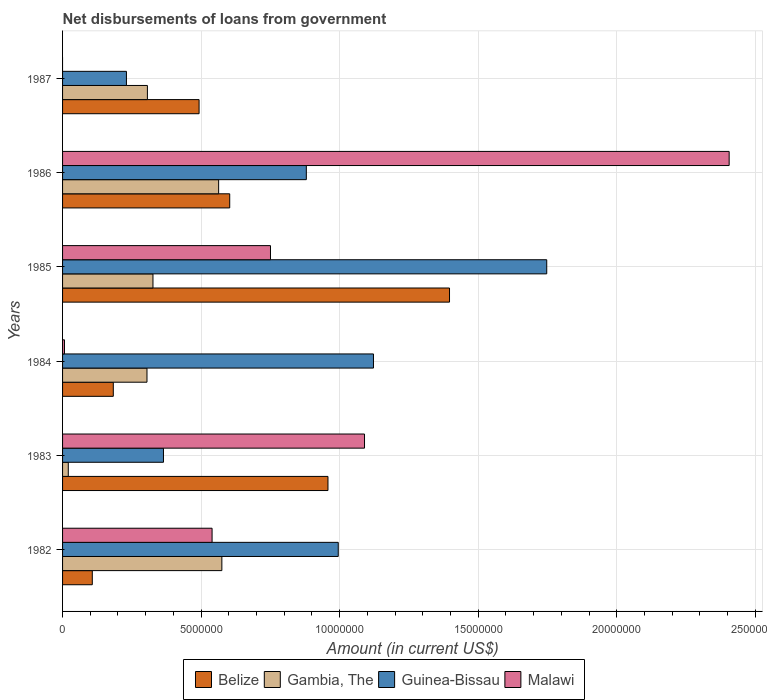How many different coloured bars are there?
Keep it short and to the point. 4. How many groups of bars are there?
Make the answer very short. 6. Are the number of bars on each tick of the Y-axis equal?
Your answer should be very brief. No. How many bars are there on the 5th tick from the top?
Your answer should be compact. 4. How many bars are there on the 6th tick from the bottom?
Offer a very short reply. 3. What is the amount of loan disbursed from government in Malawi in 1983?
Offer a very short reply. 1.09e+07. Across all years, what is the maximum amount of loan disbursed from government in Guinea-Bissau?
Provide a short and direct response. 1.75e+07. Across all years, what is the minimum amount of loan disbursed from government in Gambia, The?
Ensure brevity in your answer.  2.06e+05. In which year was the amount of loan disbursed from government in Malawi maximum?
Make the answer very short. 1986. What is the total amount of loan disbursed from government in Guinea-Bissau in the graph?
Give a very brief answer. 5.34e+07. What is the difference between the amount of loan disbursed from government in Belize in 1982 and that in 1986?
Provide a succinct answer. -4.96e+06. What is the difference between the amount of loan disbursed from government in Malawi in 1986 and the amount of loan disbursed from government in Belize in 1982?
Make the answer very short. 2.30e+07. What is the average amount of loan disbursed from government in Gambia, The per year?
Your response must be concise. 3.49e+06. In the year 1982, what is the difference between the amount of loan disbursed from government in Guinea-Bissau and amount of loan disbursed from government in Malawi?
Your response must be concise. 4.55e+06. In how many years, is the amount of loan disbursed from government in Belize greater than 12000000 US$?
Ensure brevity in your answer.  1. What is the ratio of the amount of loan disbursed from government in Guinea-Bissau in 1984 to that in 1987?
Offer a very short reply. 4.87. What is the difference between the highest and the second highest amount of loan disbursed from government in Malawi?
Provide a succinct answer. 1.32e+07. What is the difference between the highest and the lowest amount of loan disbursed from government in Belize?
Your answer should be compact. 1.29e+07. In how many years, is the amount of loan disbursed from government in Belize greater than the average amount of loan disbursed from government in Belize taken over all years?
Offer a terse response. 2. Is it the case that in every year, the sum of the amount of loan disbursed from government in Malawi and amount of loan disbursed from government in Belize is greater than the amount of loan disbursed from government in Guinea-Bissau?
Make the answer very short. No. How many bars are there?
Give a very brief answer. 23. Are all the bars in the graph horizontal?
Give a very brief answer. Yes. How many years are there in the graph?
Ensure brevity in your answer.  6. What is the difference between two consecutive major ticks on the X-axis?
Offer a very short reply. 5.00e+06. Are the values on the major ticks of X-axis written in scientific E-notation?
Provide a succinct answer. No. Does the graph contain grids?
Your response must be concise. Yes. How many legend labels are there?
Your answer should be compact. 4. How are the legend labels stacked?
Provide a short and direct response. Horizontal. What is the title of the graph?
Ensure brevity in your answer.  Net disbursements of loans from government. Does "Benin" appear as one of the legend labels in the graph?
Provide a succinct answer. No. What is the label or title of the X-axis?
Provide a succinct answer. Amount (in current US$). What is the label or title of the Y-axis?
Your response must be concise. Years. What is the Amount (in current US$) of Belize in 1982?
Your response must be concise. 1.07e+06. What is the Amount (in current US$) in Gambia, The in 1982?
Offer a terse response. 5.75e+06. What is the Amount (in current US$) of Guinea-Bissau in 1982?
Offer a very short reply. 9.95e+06. What is the Amount (in current US$) of Malawi in 1982?
Provide a short and direct response. 5.40e+06. What is the Amount (in current US$) of Belize in 1983?
Provide a short and direct response. 9.58e+06. What is the Amount (in current US$) of Gambia, The in 1983?
Keep it short and to the point. 2.06e+05. What is the Amount (in current US$) in Guinea-Bissau in 1983?
Make the answer very short. 3.64e+06. What is the Amount (in current US$) in Malawi in 1983?
Keep it short and to the point. 1.09e+07. What is the Amount (in current US$) of Belize in 1984?
Offer a very short reply. 1.83e+06. What is the Amount (in current US$) in Gambia, The in 1984?
Offer a very short reply. 3.05e+06. What is the Amount (in current US$) in Guinea-Bissau in 1984?
Your response must be concise. 1.12e+07. What is the Amount (in current US$) in Malawi in 1984?
Ensure brevity in your answer.  6.90e+04. What is the Amount (in current US$) in Belize in 1985?
Offer a terse response. 1.40e+07. What is the Amount (in current US$) of Gambia, The in 1985?
Provide a short and direct response. 3.26e+06. What is the Amount (in current US$) in Guinea-Bissau in 1985?
Ensure brevity in your answer.  1.75e+07. What is the Amount (in current US$) of Malawi in 1985?
Ensure brevity in your answer.  7.50e+06. What is the Amount (in current US$) of Belize in 1986?
Offer a terse response. 6.03e+06. What is the Amount (in current US$) in Gambia, The in 1986?
Offer a very short reply. 5.63e+06. What is the Amount (in current US$) in Guinea-Bissau in 1986?
Offer a terse response. 8.80e+06. What is the Amount (in current US$) of Malawi in 1986?
Your answer should be very brief. 2.41e+07. What is the Amount (in current US$) in Belize in 1987?
Keep it short and to the point. 4.93e+06. What is the Amount (in current US$) of Gambia, The in 1987?
Your answer should be compact. 3.06e+06. What is the Amount (in current US$) of Guinea-Bissau in 1987?
Your answer should be very brief. 2.30e+06. Across all years, what is the maximum Amount (in current US$) in Belize?
Your answer should be compact. 1.40e+07. Across all years, what is the maximum Amount (in current US$) in Gambia, The?
Keep it short and to the point. 5.75e+06. Across all years, what is the maximum Amount (in current US$) of Guinea-Bissau?
Offer a very short reply. 1.75e+07. Across all years, what is the maximum Amount (in current US$) in Malawi?
Your answer should be compact. 2.41e+07. Across all years, what is the minimum Amount (in current US$) in Belize?
Keep it short and to the point. 1.07e+06. Across all years, what is the minimum Amount (in current US$) of Gambia, The?
Your response must be concise. 2.06e+05. Across all years, what is the minimum Amount (in current US$) of Guinea-Bissau?
Your answer should be compact. 2.30e+06. Across all years, what is the minimum Amount (in current US$) in Malawi?
Make the answer very short. 0. What is the total Amount (in current US$) of Belize in the graph?
Ensure brevity in your answer.  3.74e+07. What is the total Amount (in current US$) of Gambia, The in the graph?
Your answer should be very brief. 2.10e+07. What is the total Amount (in current US$) of Guinea-Bissau in the graph?
Provide a short and direct response. 5.34e+07. What is the total Amount (in current US$) of Malawi in the graph?
Offer a terse response. 4.79e+07. What is the difference between the Amount (in current US$) in Belize in 1982 and that in 1983?
Your answer should be compact. -8.51e+06. What is the difference between the Amount (in current US$) in Gambia, The in 1982 and that in 1983?
Your response must be concise. 5.54e+06. What is the difference between the Amount (in current US$) of Guinea-Bissau in 1982 and that in 1983?
Give a very brief answer. 6.31e+06. What is the difference between the Amount (in current US$) in Malawi in 1982 and that in 1983?
Offer a very short reply. -5.50e+06. What is the difference between the Amount (in current US$) of Belize in 1982 and that in 1984?
Ensure brevity in your answer.  -7.58e+05. What is the difference between the Amount (in current US$) in Gambia, The in 1982 and that in 1984?
Offer a terse response. 2.70e+06. What is the difference between the Amount (in current US$) of Guinea-Bissau in 1982 and that in 1984?
Your answer should be compact. -1.27e+06. What is the difference between the Amount (in current US$) in Malawi in 1982 and that in 1984?
Make the answer very short. 5.33e+06. What is the difference between the Amount (in current US$) of Belize in 1982 and that in 1985?
Keep it short and to the point. -1.29e+07. What is the difference between the Amount (in current US$) of Gambia, The in 1982 and that in 1985?
Your answer should be compact. 2.49e+06. What is the difference between the Amount (in current US$) in Guinea-Bissau in 1982 and that in 1985?
Your answer should be very brief. -7.52e+06. What is the difference between the Amount (in current US$) of Malawi in 1982 and that in 1985?
Provide a short and direct response. -2.11e+06. What is the difference between the Amount (in current US$) of Belize in 1982 and that in 1986?
Keep it short and to the point. -4.96e+06. What is the difference between the Amount (in current US$) of Gambia, The in 1982 and that in 1986?
Your answer should be very brief. 1.16e+05. What is the difference between the Amount (in current US$) of Guinea-Bissau in 1982 and that in 1986?
Make the answer very short. 1.15e+06. What is the difference between the Amount (in current US$) of Malawi in 1982 and that in 1986?
Your response must be concise. -1.87e+07. What is the difference between the Amount (in current US$) in Belize in 1982 and that in 1987?
Your answer should be compact. -3.85e+06. What is the difference between the Amount (in current US$) of Gambia, The in 1982 and that in 1987?
Give a very brief answer. 2.69e+06. What is the difference between the Amount (in current US$) of Guinea-Bissau in 1982 and that in 1987?
Offer a terse response. 7.64e+06. What is the difference between the Amount (in current US$) in Belize in 1983 and that in 1984?
Offer a very short reply. 7.75e+06. What is the difference between the Amount (in current US$) of Gambia, The in 1983 and that in 1984?
Your answer should be very brief. -2.84e+06. What is the difference between the Amount (in current US$) of Guinea-Bissau in 1983 and that in 1984?
Your answer should be compact. -7.58e+06. What is the difference between the Amount (in current US$) of Malawi in 1983 and that in 1984?
Your response must be concise. 1.08e+07. What is the difference between the Amount (in current US$) of Belize in 1983 and that in 1985?
Offer a terse response. -4.39e+06. What is the difference between the Amount (in current US$) of Gambia, The in 1983 and that in 1985?
Your answer should be compact. -3.06e+06. What is the difference between the Amount (in current US$) in Guinea-Bissau in 1983 and that in 1985?
Your answer should be very brief. -1.38e+07. What is the difference between the Amount (in current US$) in Malawi in 1983 and that in 1985?
Keep it short and to the point. 3.39e+06. What is the difference between the Amount (in current US$) in Belize in 1983 and that in 1986?
Make the answer very short. 3.55e+06. What is the difference between the Amount (in current US$) of Gambia, The in 1983 and that in 1986?
Give a very brief answer. -5.43e+06. What is the difference between the Amount (in current US$) in Guinea-Bissau in 1983 and that in 1986?
Ensure brevity in your answer.  -5.16e+06. What is the difference between the Amount (in current US$) in Malawi in 1983 and that in 1986?
Offer a terse response. -1.32e+07. What is the difference between the Amount (in current US$) of Belize in 1983 and that in 1987?
Keep it short and to the point. 4.65e+06. What is the difference between the Amount (in current US$) of Gambia, The in 1983 and that in 1987?
Provide a short and direct response. -2.86e+06. What is the difference between the Amount (in current US$) in Guinea-Bissau in 1983 and that in 1987?
Your response must be concise. 1.34e+06. What is the difference between the Amount (in current US$) in Belize in 1984 and that in 1985?
Make the answer very short. -1.21e+07. What is the difference between the Amount (in current US$) of Gambia, The in 1984 and that in 1985?
Your answer should be compact. -2.16e+05. What is the difference between the Amount (in current US$) in Guinea-Bissau in 1984 and that in 1985?
Ensure brevity in your answer.  -6.25e+06. What is the difference between the Amount (in current US$) in Malawi in 1984 and that in 1985?
Offer a very short reply. -7.44e+06. What is the difference between the Amount (in current US$) in Belize in 1984 and that in 1986?
Keep it short and to the point. -4.20e+06. What is the difference between the Amount (in current US$) in Gambia, The in 1984 and that in 1986?
Offer a terse response. -2.59e+06. What is the difference between the Amount (in current US$) of Guinea-Bissau in 1984 and that in 1986?
Give a very brief answer. 2.42e+06. What is the difference between the Amount (in current US$) of Malawi in 1984 and that in 1986?
Make the answer very short. -2.40e+07. What is the difference between the Amount (in current US$) of Belize in 1984 and that in 1987?
Give a very brief answer. -3.10e+06. What is the difference between the Amount (in current US$) of Gambia, The in 1984 and that in 1987?
Your answer should be very brief. -1.50e+04. What is the difference between the Amount (in current US$) of Guinea-Bissau in 1984 and that in 1987?
Give a very brief answer. 8.92e+06. What is the difference between the Amount (in current US$) in Belize in 1985 and that in 1986?
Your answer should be very brief. 7.93e+06. What is the difference between the Amount (in current US$) of Gambia, The in 1985 and that in 1986?
Make the answer very short. -2.37e+06. What is the difference between the Amount (in current US$) in Guinea-Bissau in 1985 and that in 1986?
Provide a succinct answer. 8.68e+06. What is the difference between the Amount (in current US$) of Malawi in 1985 and that in 1986?
Give a very brief answer. -1.66e+07. What is the difference between the Amount (in current US$) of Belize in 1985 and that in 1987?
Make the answer very short. 9.04e+06. What is the difference between the Amount (in current US$) of Gambia, The in 1985 and that in 1987?
Keep it short and to the point. 2.01e+05. What is the difference between the Amount (in current US$) of Guinea-Bissau in 1985 and that in 1987?
Make the answer very short. 1.52e+07. What is the difference between the Amount (in current US$) in Belize in 1986 and that in 1987?
Your answer should be compact. 1.11e+06. What is the difference between the Amount (in current US$) in Gambia, The in 1986 and that in 1987?
Your answer should be very brief. 2.57e+06. What is the difference between the Amount (in current US$) of Guinea-Bissau in 1986 and that in 1987?
Your answer should be compact. 6.49e+06. What is the difference between the Amount (in current US$) in Belize in 1982 and the Amount (in current US$) in Gambia, The in 1983?
Give a very brief answer. 8.67e+05. What is the difference between the Amount (in current US$) in Belize in 1982 and the Amount (in current US$) in Guinea-Bissau in 1983?
Offer a very short reply. -2.57e+06. What is the difference between the Amount (in current US$) of Belize in 1982 and the Amount (in current US$) of Malawi in 1983?
Keep it short and to the point. -9.82e+06. What is the difference between the Amount (in current US$) in Gambia, The in 1982 and the Amount (in current US$) in Guinea-Bissau in 1983?
Your answer should be very brief. 2.11e+06. What is the difference between the Amount (in current US$) in Gambia, The in 1982 and the Amount (in current US$) in Malawi in 1983?
Your response must be concise. -5.15e+06. What is the difference between the Amount (in current US$) in Guinea-Bissau in 1982 and the Amount (in current US$) in Malawi in 1983?
Keep it short and to the point. -9.48e+05. What is the difference between the Amount (in current US$) of Belize in 1982 and the Amount (in current US$) of Gambia, The in 1984?
Your answer should be very brief. -1.97e+06. What is the difference between the Amount (in current US$) in Belize in 1982 and the Amount (in current US$) in Guinea-Bissau in 1984?
Your answer should be very brief. -1.01e+07. What is the difference between the Amount (in current US$) in Belize in 1982 and the Amount (in current US$) in Malawi in 1984?
Your answer should be compact. 1.00e+06. What is the difference between the Amount (in current US$) of Gambia, The in 1982 and the Amount (in current US$) of Guinea-Bissau in 1984?
Provide a short and direct response. -5.47e+06. What is the difference between the Amount (in current US$) of Gambia, The in 1982 and the Amount (in current US$) of Malawi in 1984?
Make the answer very short. 5.68e+06. What is the difference between the Amount (in current US$) in Guinea-Bissau in 1982 and the Amount (in current US$) in Malawi in 1984?
Give a very brief answer. 9.88e+06. What is the difference between the Amount (in current US$) in Belize in 1982 and the Amount (in current US$) in Gambia, The in 1985?
Make the answer very short. -2.19e+06. What is the difference between the Amount (in current US$) of Belize in 1982 and the Amount (in current US$) of Guinea-Bissau in 1985?
Provide a succinct answer. -1.64e+07. What is the difference between the Amount (in current US$) in Belize in 1982 and the Amount (in current US$) in Malawi in 1985?
Your response must be concise. -6.43e+06. What is the difference between the Amount (in current US$) in Gambia, The in 1982 and the Amount (in current US$) in Guinea-Bissau in 1985?
Make the answer very short. -1.17e+07. What is the difference between the Amount (in current US$) of Gambia, The in 1982 and the Amount (in current US$) of Malawi in 1985?
Ensure brevity in your answer.  -1.76e+06. What is the difference between the Amount (in current US$) of Guinea-Bissau in 1982 and the Amount (in current US$) of Malawi in 1985?
Your answer should be compact. 2.45e+06. What is the difference between the Amount (in current US$) of Belize in 1982 and the Amount (in current US$) of Gambia, The in 1986?
Make the answer very short. -4.56e+06. What is the difference between the Amount (in current US$) in Belize in 1982 and the Amount (in current US$) in Guinea-Bissau in 1986?
Provide a succinct answer. -7.72e+06. What is the difference between the Amount (in current US$) in Belize in 1982 and the Amount (in current US$) in Malawi in 1986?
Offer a very short reply. -2.30e+07. What is the difference between the Amount (in current US$) of Gambia, The in 1982 and the Amount (in current US$) of Guinea-Bissau in 1986?
Your answer should be very brief. -3.05e+06. What is the difference between the Amount (in current US$) of Gambia, The in 1982 and the Amount (in current US$) of Malawi in 1986?
Your answer should be very brief. -1.83e+07. What is the difference between the Amount (in current US$) in Guinea-Bissau in 1982 and the Amount (in current US$) in Malawi in 1986?
Your answer should be very brief. -1.41e+07. What is the difference between the Amount (in current US$) in Belize in 1982 and the Amount (in current US$) in Gambia, The in 1987?
Give a very brief answer. -1.99e+06. What is the difference between the Amount (in current US$) of Belize in 1982 and the Amount (in current US$) of Guinea-Bissau in 1987?
Offer a terse response. -1.23e+06. What is the difference between the Amount (in current US$) of Gambia, The in 1982 and the Amount (in current US$) of Guinea-Bissau in 1987?
Give a very brief answer. 3.44e+06. What is the difference between the Amount (in current US$) of Belize in 1983 and the Amount (in current US$) of Gambia, The in 1984?
Provide a short and direct response. 6.53e+06. What is the difference between the Amount (in current US$) in Belize in 1983 and the Amount (in current US$) in Guinea-Bissau in 1984?
Ensure brevity in your answer.  -1.64e+06. What is the difference between the Amount (in current US$) of Belize in 1983 and the Amount (in current US$) of Malawi in 1984?
Your response must be concise. 9.51e+06. What is the difference between the Amount (in current US$) in Gambia, The in 1983 and the Amount (in current US$) in Guinea-Bissau in 1984?
Your answer should be compact. -1.10e+07. What is the difference between the Amount (in current US$) of Gambia, The in 1983 and the Amount (in current US$) of Malawi in 1984?
Provide a short and direct response. 1.37e+05. What is the difference between the Amount (in current US$) of Guinea-Bissau in 1983 and the Amount (in current US$) of Malawi in 1984?
Ensure brevity in your answer.  3.57e+06. What is the difference between the Amount (in current US$) in Belize in 1983 and the Amount (in current US$) in Gambia, The in 1985?
Your answer should be very brief. 6.32e+06. What is the difference between the Amount (in current US$) of Belize in 1983 and the Amount (in current US$) of Guinea-Bissau in 1985?
Make the answer very short. -7.90e+06. What is the difference between the Amount (in current US$) of Belize in 1983 and the Amount (in current US$) of Malawi in 1985?
Offer a terse response. 2.08e+06. What is the difference between the Amount (in current US$) in Gambia, The in 1983 and the Amount (in current US$) in Guinea-Bissau in 1985?
Provide a succinct answer. -1.73e+07. What is the difference between the Amount (in current US$) in Gambia, The in 1983 and the Amount (in current US$) in Malawi in 1985?
Keep it short and to the point. -7.30e+06. What is the difference between the Amount (in current US$) of Guinea-Bissau in 1983 and the Amount (in current US$) of Malawi in 1985?
Your answer should be very brief. -3.86e+06. What is the difference between the Amount (in current US$) in Belize in 1983 and the Amount (in current US$) in Gambia, The in 1986?
Give a very brief answer. 3.95e+06. What is the difference between the Amount (in current US$) of Belize in 1983 and the Amount (in current US$) of Guinea-Bissau in 1986?
Offer a very short reply. 7.81e+05. What is the difference between the Amount (in current US$) in Belize in 1983 and the Amount (in current US$) in Malawi in 1986?
Make the answer very short. -1.45e+07. What is the difference between the Amount (in current US$) of Gambia, The in 1983 and the Amount (in current US$) of Guinea-Bissau in 1986?
Offer a very short reply. -8.59e+06. What is the difference between the Amount (in current US$) of Gambia, The in 1983 and the Amount (in current US$) of Malawi in 1986?
Your answer should be very brief. -2.39e+07. What is the difference between the Amount (in current US$) of Guinea-Bissau in 1983 and the Amount (in current US$) of Malawi in 1986?
Make the answer very short. -2.04e+07. What is the difference between the Amount (in current US$) in Belize in 1983 and the Amount (in current US$) in Gambia, The in 1987?
Your response must be concise. 6.52e+06. What is the difference between the Amount (in current US$) of Belize in 1983 and the Amount (in current US$) of Guinea-Bissau in 1987?
Your answer should be compact. 7.27e+06. What is the difference between the Amount (in current US$) of Gambia, The in 1983 and the Amount (in current US$) of Guinea-Bissau in 1987?
Offer a very short reply. -2.10e+06. What is the difference between the Amount (in current US$) in Belize in 1984 and the Amount (in current US$) in Gambia, The in 1985?
Your answer should be compact. -1.43e+06. What is the difference between the Amount (in current US$) in Belize in 1984 and the Amount (in current US$) in Guinea-Bissau in 1985?
Your answer should be compact. -1.56e+07. What is the difference between the Amount (in current US$) of Belize in 1984 and the Amount (in current US$) of Malawi in 1985?
Offer a very short reply. -5.67e+06. What is the difference between the Amount (in current US$) in Gambia, The in 1984 and the Amount (in current US$) in Guinea-Bissau in 1985?
Offer a very short reply. -1.44e+07. What is the difference between the Amount (in current US$) of Gambia, The in 1984 and the Amount (in current US$) of Malawi in 1985?
Your response must be concise. -4.46e+06. What is the difference between the Amount (in current US$) of Guinea-Bissau in 1984 and the Amount (in current US$) of Malawi in 1985?
Provide a succinct answer. 3.72e+06. What is the difference between the Amount (in current US$) of Belize in 1984 and the Amount (in current US$) of Gambia, The in 1986?
Provide a short and direct response. -3.80e+06. What is the difference between the Amount (in current US$) of Belize in 1984 and the Amount (in current US$) of Guinea-Bissau in 1986?
Provide a succinct answer. -6.97e+06. What is the difference between the Amount (in current US$) of Belize in 1984 and the Amount (in current US$) of Malawi in 1986?
Keep it short and to the point. -2.22e+07. What is the difference between the Amount (in current US$) in Gambia, The in 1984 and the Amount (in current US$) in Guinea-Bissau in 1986?
Your answer should be compact. -5.75e+06. What is the difference between the Amount (in current US$) of Gambia, The in 1984 and the Amount (in current US$) of Malawi in 1986?
Keep it short and to the point. -2.10e+07. What is the difference between the Amount (in current US$) of Guinea-Bissau in 1984 and the Amount (in current US$) of Malawi in 1986?
Make the answer very short. -1.28e+07. What is the difference between the Amount (in current US$) of Belize in 1984 and the Amount (in current US$) of Gambia, The in 1987?
Keep it short and to the point. -1.23e+06. What is the difference between the Amount (in current US$) in Belize in 1984 and the Amount (in current US$) in Guinea-Bissau in 1987?
Make the answer very short. -4.74e+05. What is the difference between the Amount (in current US$) in Gambia, The in 1984 and the Amount (in current US$) in Guinea-Bissau in 1987?
Provide a short and direct response. 7.42e+05. What is the difference between the Amount (in current US$) in Belize in 1985 and the Amount (in current US$) in Gambia, The in 1986?
Give a very brief answer. 8.33e+06. What is the difference between the Amount (in current US$) in Belize in 1985 and the Amount (in current US$) in Guinea-Bissau in 1986?
Make the answer very short. 5.17e+06. What is the difference between the Amount (in current US$) of Belize in 1985 and the Amount (in current US$) of Malawi in 1986?
Provide a short and direct response. -1.01e+07. What is the difference between the Amount (in current US$) of Gambia, The in 1985 and the Amount (in current US$) of Guinea-Bissau in 1986?
Your response must be concise. -5.54e+06. What is the difference between the Amount (in current US$) in Gambia, The in 1985 and the Amount (in current US$) in Malawi in 1986?
Ensure brevity in your answer.  -2.08e+07. What is the difference between the Amount (in current US$) in Guinea-Bissau in 1985 and the Amount (in current US$) in Malawi in 1986?
Ensure brevity in your answer.  -6.58e+06. What is the difference between the Amount (in current US$) of Belize in 1985 and the Amount (in current US$) of Gambia, The in 1987?
Make the answer very short. 1.09e+07. What is the difference between the Amount (in current US$) of Belize in 1985 and the Amount (in current US$) of Guinea-Bissau in 1987?
Give a very brief answer. 1.17e+07. What is the difference between the Amount (in current US$) of Gambia, The in 1985 and the Amount (in current US$) of Guinea-Bissau in 1987?
Your response must be concise. 9.58e+05. What is the difference between the Amount (in current US$) of Belize in 1986 and the Amount (in current US$) of Gambia, The in 1987?
Your response must be concise. 2.97e+06. What is the difference between the Amount (in current US$) of Belize in 1986 and the Amount (in current US$) of Guinea-Bissau in 1987?
Offer a very short reply. 3.73e+06. What is the difference between the Amount (in current US$) in Gambia, The in 1986 and the Amount (in current US$) in Guinea-Bissau in 1987?
Offer a very short reply. 3.33e+06. What is the average Amount (in current US$) of Belize per year?
Keep it short and to the point. 6.23e+06. What is the average Amount (in current US$) in Gambia, The per year?
Your response must be concise. 3.49e+06. What is the average Amount (in current US$) in Guinea-Bissau per year?
Provide a succinct answer. 8.90e+06. What is the average Amount (in current US$) in Malawi per year?
Make the answer very short. 7.99e+06. In the year 1982, what is the difference between the Amount (in current US$) in Belize and Amount (in current US$) in Gambia, The?
Keep it short and to the point. -4.68e+06. In the year 1982, what is the difference between the Amount (in current US$) of Belize and Amount (in current US$) of Guinea-Bissau?
Your response must be concise. -8.88e+06. In the year 1982, what is the difference between the Amount (in current US$) of Belize and Amount (in current US$) of Malawi?
Give a very brief answer. -4.32e+06. In the year 1982, what is the difference between the Amount (in current US$) of Gambia, The and Amount (in current US$) of Guinea-Bissau?
Your answer should be compact. -4.20e+06. In the year 1982, what is the difference between the Amount (in current US$) in Gambia, The and Amount (in current US$) in Malawi?
Keep it short and to the point. 3.53e+05. In the year 1982, what is the difference between the Amount (in current US$) in Guinea-Bissau and Amount (in current US$) in Malawi?
Keep it short and to the point. 4.55e+06. In the year 1983, what is the difference between the Amount (in current US$) of Belize and Amount (in current US$) of Gambia, The?
Your answer should be compact. 9.37e+06. In the year 1983, what is the difference between the Amount (in current US$) in Belize and Amount (in current US$) in Guinea-Bissau?
Your answer should be compact. 5.94e+06. In the year 1983, what is the difference between the Amount (in current US$) of Belize and Amount (in current US$) of Malawi?
Your answer should be compact. -1.32e+06. In the year 1983, what is the difference between the Amount (in current US$) in Gambia, The and Amount (in current US$) in Guinea-Bissau?
Ensure brevity in your answer.  -3.44e+06. In the year 1983, what is the difference between the Amount (in current US$) in Gambia, The and Amount (in current US$) in Malawi?
Offer a very short reply. -1.07e+07. In the year 1983, what is the difference between the Amount (in current US$) in Guinea-Bissau and Amount (in current US$) in Malawi?
Your answer should be compact. -7.26e+06. In the year 1984, what is the difference between the Amount (in current US$) of Belize and Amount (in current US$) of Gambia, The?
Give a very brief answer. -1.22e+06. In the year 1984, what is the difference between the Amount (in current US$) of Belize and Amount (in current US$) of Guinea-Bissau?
Your answer should be compact. -9.39e+06. In the year 1984, what is the difference between the Amount (in current US$) of Belize and Amount (in current US$) of Malawi?
Give a very brief answer. 1.76e+06. In the year 1984, what is the difference between the Amount (in current US$) in Gambia, The and Amount (in current US$) in Guinea-Bissau?
Provide a succinct answer. -8.17e+06. In the year 1984, what is the difference between the Amount (in current US$) in Gambia, The and Amount (in current US$) in Malawi?
Ensure brevity in your answer.  2.98e+06. In the year 1984, what is the difference between the Amount (in current US$) of Guinea-Bissau and Amount (in current US$) of Malawi?
Make the answer very short. 1.12e+07. In the year 1985, what is the difference between the Amount (in current US$) in Belize and Amount (in current US$) in Gambia, The?
Offer a terse response. 1.07e+07. In the year 1985, what is the difference between the Amount (in current US$) in Belize and Amount (in current US$) in Guinea-Bissau?
Offer a very short reply. -3.51e+06. In the year 1985, what is the difference between the Amount (in current US$) of Belize and Amount (in current US$) of Malawi?
Offer a terse response. 6.46e+06. In the year 1985, what is the difference between the Amount (in current US$) of Gambia, The and Amount (in current US$) of Guinea-Bissau?
Your answer should be compact. -1.42e+07. In the year 1985, what is the difference between the Amount (in current US$) of Gambia, The and Amount (in current US$) of Malawi?
Offer a terse response. -4.24e+06. In the year 1985, what is the difference between the Amount (in current US$) of Guinea-Bissau and Amount (in current US$) of Malawi?
Your answer should be compact. 9.97e+06. In the year 1986, what is the difference between the Amount (in current US$) in Belize and Amount (in current US$) in Gambia, The?
Keep it short and to the point. 4.00e+05. In the year 1986, what is the difference between the Amount (in current US$) of Belize and Amount (in current US$) of Guinea-Bissau?
Your answer should be very brief. -2.76e+06. In the year 1986, what is the difference between the Amount (in current US$) in Belize and Amount (in current US$) in Malawi?
Your answer should be very brief. -1.80e+07. In the year 1986, what is the difference between the Amount (in current US$) of Gambia, The and Amount (in current US$) of Guinea-Bissau?
Offer a terse response. -3.16e+06. In the year 1986, what is the difference between the Amount (in current US$) of Gambia, The and Amount (in current US$) of Malawi?
Keep it short and to the point. -1.84e+07. In the year 1986, what is the difference between the Amount (in current US$) of Guinea-Bissau and Amount (in current US$) of Malawi?
Your response must be concise. -1.53e+07. In the year 1987, what is the difference between the Amount (in current US$) in Belize and Amount (in current US$) in Gambia, The?
Your answer should be compact. 1.86e+06. In the year 1987, what is the difference between the Amount (in current US$) in Belize and Amount (in current US$) in Guinea-Bissau?
Ensure brevity in your answer.  2.62e+06. In the year 1987, what is the difference between the Amount (in current US$) in Gambia, The and Amount (in current US$) in Guinea-Bissau?
Your answer should be very brief. 7.57e+05. What is the ratio of the Amount (in current US$) in Belize in 1982 to that in 1983?
Provide a succinct answer. 0.11. What is the ratio of the Amount (in current US$) of Gambia, The in 1982 to that in 1983?
Your answer should be very brief. 27.91. What is the ratio of the Amount (in current US$) in Guinea-Bissau in 1982 to that in 1983?
Keep it short and to the point. 2.73. What is the ratio of the Amount (in current US$) in Malawi in 1982 to that in 1983?
Provide a short and direct response. 0.5. What is the ratio of the Amount (in current US$) in Belize in 1982 to that in 1984?
Make the answer very short. 0.59. What is the ratio of the Amount (in current US$) of Gambia, The in 1982 to that in 1984?
Provide a short and direct response. 1.89. What is the ratio of the Amount (in current US$) of Guinea-Bissau in 1982 to that in 1984?
Your answer should be compact. 0.89. What is the ratio of the Amount (in current US$) of Malawi in 1982 to that in 1984?
Offer a terse response. 78.2. What is the ratio of the Amount (in current US$) of Belize in 1982 to that in 1985?
Your answer should be very brief. 0.08. What is the ratio of the Amount (in current US$) in Gambia, The in 1982 to that in 1985?
Your answer should be compact. 1.76. What is the ratio of the Amount (in current US$) of Guinea-Bissau in 1982 to that in 1985?
Your answer should be compact. 0.57. What is the ratio of the Amount (in current US$) in Malawi in 1982 to that in 1985?
Your answer should be compact. 0.72. What is the ratio of the Amount (in current US$) of Belize in 1982 to that in 1986?
Your answer should be very brief. 0.18. What is the ratio of the Amount (in current US$) in Gambia, The in 1982 to that in 1986?
Ensure brevity in your answer.  1.02. What is the ratio of the Amount (in current US$) in Guinea-Bissau in 1982 to that in 1986?
Offer a very short reply. 1.13. What is the ratio of the Amount (in current US$) in Malawi in 1982 to that in 1986?
Offer a very short reply. 0.22. What is the ratio of the Amount (in current US$) in Belize in 1982 to that in 1987?
Offer a terse response. 0.22. What is the ratio of the Amount (in current US$) in Gambia, The in 1982 to that in 1987?
Offer a terse response. 1.88. What is the ratio of the Amount (in current US$) of Guinea-Bissau in 1982 to that in 1987?
Your response must be concise. 4.32. What is the ratio of the Amount (in current US$) of Belize in 1983 to that in 1984?
Your answer should be very brief. 5.23. What is the ratio of the Amount (in current US$) of Gambia, The in 1983 to that in 1984?
Ensure brevity in your answer.  0.07. What is the ratio of the Amount (in current US$) in Guinea-Bissau in 1983 to that in 1984?
Keep it short and to the point. 0.32. What is the ratio of the Amount (in current US$) in Malawi in 1983 to that in 1984?
Keep it short and to the point. 157.94. What is the ratio of the Amount (in current US$) in Belize in 1983 to that in 1985?
Provide a succinct answer. 0.69. What is the ratio of the Amount (in current US$) of Gambia, The in 1983 to that in 1985?
Your response must be concise. 0.06. What is the ratio of the Amount (in current US$) in Guinea-Bissau in 1983 to that in 1985?
Your answer should be compact. 0.21. What is the ratio of the Amount (in current US$) of Malawi in 1983 to that in 1985?
Ensure brevity in your answer.  1.45. What is the ratio of the Amount (in current US$) in Belize in 1983 to that in 1986?
Make the answer very short. 1.59. What is the ratio of the Amount (in current US$) in Gambia, The in 1983 to that in 1986?
Offer a very short reply. 0.04. What is the ratio of the Amount (in current US$) in Guinea-Bissau in 1983 to that in 1986?
Ensure brevity in your answer.  0.41. What is the ratio of the Amount (in current US$) in Malawi in 1983 to that in 1986?
Give a very brief answer. 0.45. What is the ratio of the Amount (in current US$) in Belize in 1983 to that in 1987?
Offer a terse response. 1.94. What is the ratio of the Amount (in current US$) of Gambia, The in 1983 to that in 1987?
Offer a very short reply. 0.07. What is the ratio of the Amount (in current US$) of Guinea-Bissau in 1983 to that in 1987?
Provide a succinct answer. 1.58. What is the ratio of the Amount (in current US$) in Belize in 1984 to that in 1985?
Offer a very short reply. 0.13. What is the ratio of the Amount (in current US$) of Gambia, The in 1984 to that in 1985?
Give a very brief answer. 0.93. What is the ratio of the Amount (in current US$) of Guinea-Bissau in 1984 to that in 1985?
Make the answer very short. 0.64. What is the ratio of the Amount (in current US$) in Malawi in 1984 to that in 1985?
Provide a succinct answer. 0.01. What is the ratio of the Amount (in current US$) in Belize in 1984 to that in 1986?
Keep it short and to the point. 0.3. What is the ratio of the Amount (in current US$) in Gambia, The in 1984 to that in 1986?
Offer a terse response. 0.54. What is the ratio of the Amount (in current US$) of Guinea-Bissau in 1984 to that in 1986?
Your answer should be compact. 1.28. What is the ratio of the Amount (in current US$) in Malawi in 1984 to that in 1986?
Offer a very short reply. 0. What is the ratio of the Amount (in current US$) in Belize in 1984 to that in 1987?
Your response must be concise. 0.37. What is the ratio of the Amount (in current US$) in Guinea-Bissau in 1984 to that in 1987?
Offer a very short reply. 4.87. What is the ratio of the Amount (in current US$) in Belize in 1985 to that in 1986?
Provide a succinct answer. 2.31. What is the ratio of the Amount (in current US$) in Gambia, The in 1985 to that in 1986?
Offer a very short reply. 0.58. What is the ratio of the Amount (in current US$) in Guinea-Bissau in 1985 to that in 1986?
Provide a short and direct response. 1.99. What is the ratio of the Amount (in current US$) of Malawi in 1985 to that in 1986?
Give a very brief answer. 0.31. What is the ratio of the Amount (in current US$) in Belize in 1985 to that in 1987?
Keep it short and to the point. 2.83. What is the ratio of the Amount (in current US$) in Gambia, The in 1985 to that in 1987?
Your response must be concise. 1.07. What is the ratio of the Amount (in current US$) in Guinea-Bissau in 1985 to that in 1987?
Your answer should be compact. 7.58. What is the ratio of the Amount (in current US$) of Belize in 1986 to that in 1987?
Ensure brevity in your answer.  1.22. What is the ratio of the Amount (in current US$) of Gambia, The in 1986 to that in 1987?
Offer a very short reply. 1.84. What is the ratio of the Amount (in current US$) of Guinea-Bissau in 1986 to that in 1987?
Your answer should be compact. 3.82. What is the difference between the highest and the second highest Amount (in current US$) in Belize?
Make the answer very short. 4.39e+06. What is the difference between the highest and the second highest Amount (in current US$) in Gambia, The?
Your answer should be very brief. 1.16e+05. What is the difference between the highest and the second highest Amount (in current US$) of Guinea-Bissau?
Offer a very short reply. 6.25e+06. What is the difference between the highest and the second highest Amount (in current US$) of Malawi?
Your answer should be compact. 1.32e+07. What is the difference between the highest and the lowest Amount (in current US$) in Belize?
Provide a short and direct response. 1.29e+07. What is the difference between the highest and the lowest Amount (in current US$) of Gambia, The?
Offer a very short reply. 5.54e+06. What is the difference between the highest and the lowest Amount (in current US$) in Guinea-Bissau?
Provide a succinct answer. 1.52e+07. What is the difference between the highest and the lowest Amount (in current US$) of Malawi?
Keep it short and to the point. 2.41e+07. 